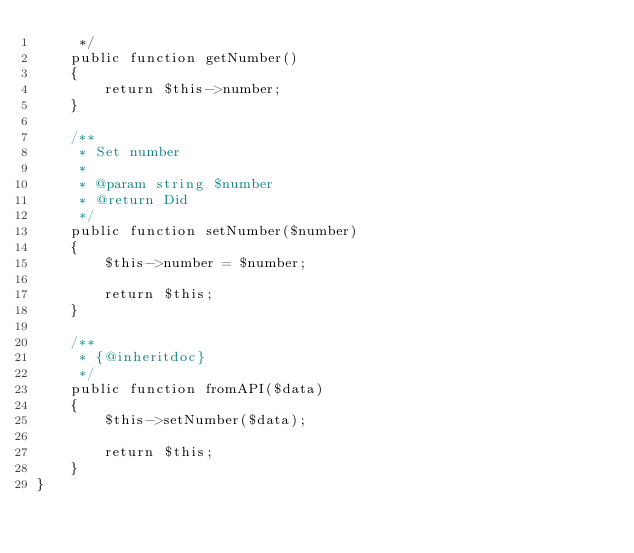Convert code to text. <code><loc_0><loc_0><loc_500><loc_500><_PHP_>     */
    public function getNumber()
    {
        return $this->number;
    }

    /**
     * Set number
     *
     * @param string $number
     * @return Did
     */
    public function setNumber($number)
    {
        $this->number = $number;

        return $this;
    }

    /**
     * {@inheritdoc}
     */
    public function fromAPI($data)
    {
        $this->setNumber($data);

        return $this;
    }
}
</code> 